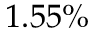<formula> <loc_0><loc_0><loc_500><loc_500>1 . 5 5 \%</formula> 